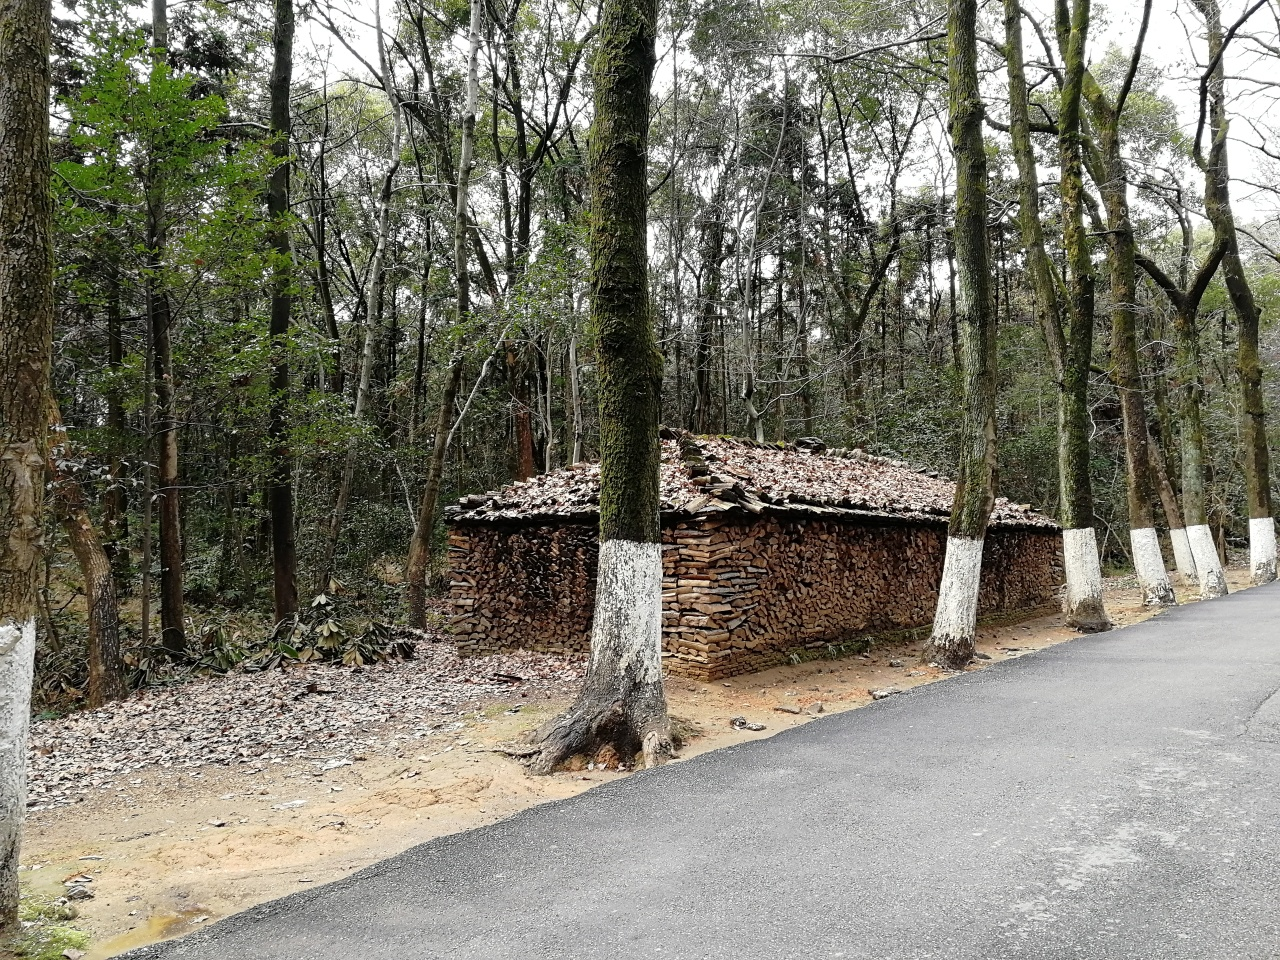What's the function of the structure in the image? The structure in the image appears to be a woodpile shelter, used for storing cut firewood and protecting it from the elements, such as rain or snow, ensuring it stays dry and is ready for use during colder months. 